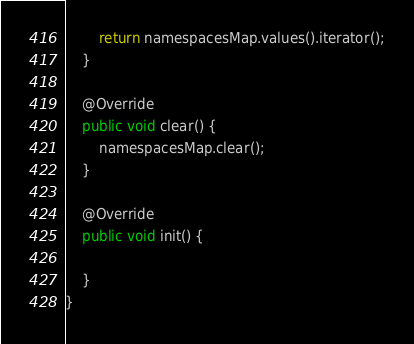Convert code to text. <code><loc_0><loc_0><loc_500><loc_500><_Java_>		return namespacesMap.values().iterator();
	}

	@Override
	public void clear() {
		namespacesMap.clear();
	}

	@Override
	public void init() {

	}
}
</code> 